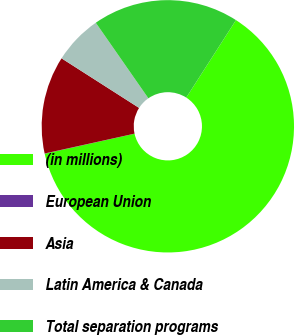Convert chart to OTSL. <chart><loc_0><loc_0><loc_500><loc_500><pie_chart><fcel>(in millions)<fcel>European Union<fcel>Asia<fcel>Latin America & Canada<fcel>Total separation programs<nl><fcel>62.43%<fcel>0.03%<fcel>12.51%<fcel>6.27%<fcel>18.75%<nl></chart> 